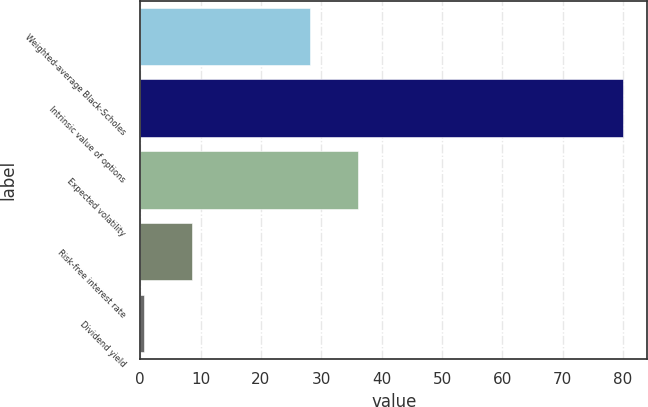<chart> <loc_0><loc_0><loc_500><loc_500><bar_chart><fcel>Weighted-average Black-Scholes<fcel>Intrinsic value of options<fcel>Expected volatility<fcel>Risk-free interest rate<fcel>Dividend yield<nl><fcel>28.12<fcel>80<fcel>36.06<fcel>8.5<fcel>0.56<nl></chart> 